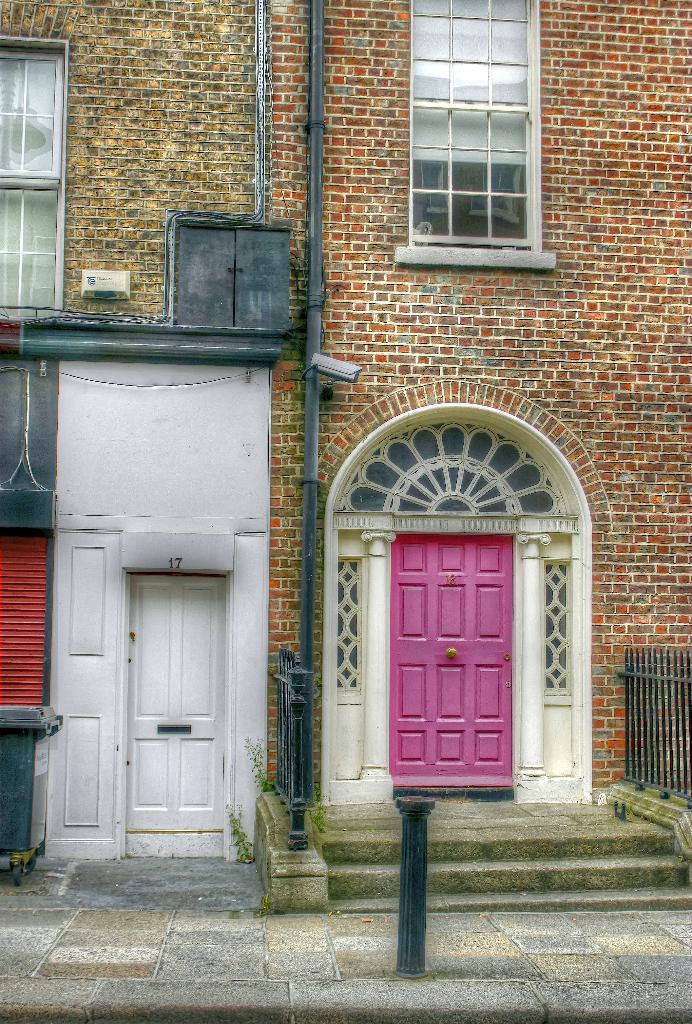Could you give a brief overview of what you see in this image? In this image, we can see the wall with some windows, doors and other objects. We can also see some stairs and the fence. We can see the ground and a pole. We can also see an object on the left. 